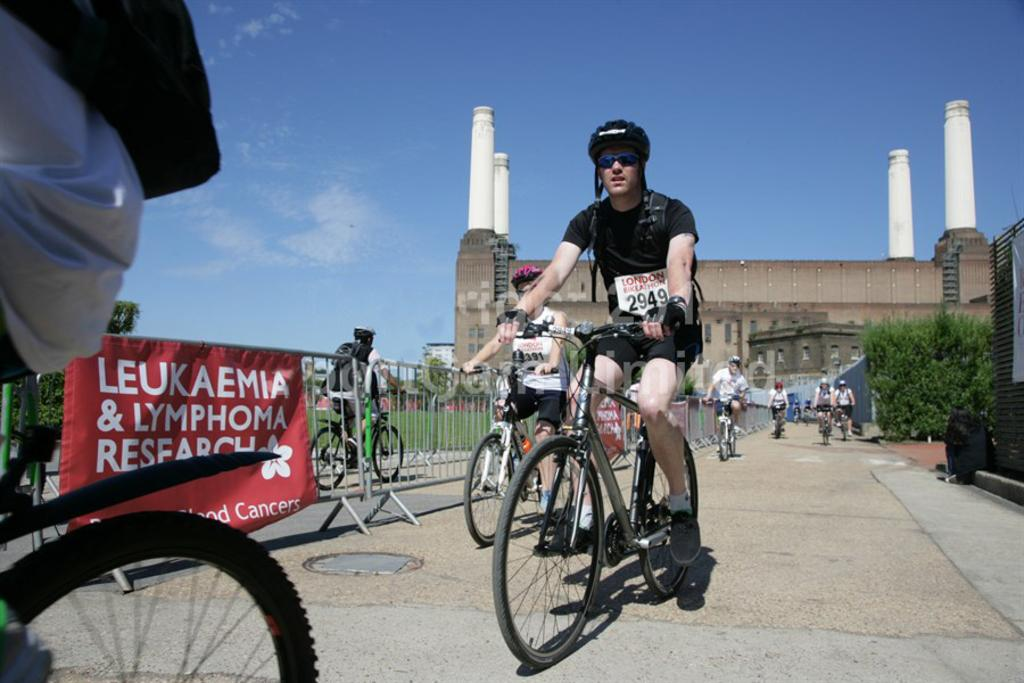What are the persons in the image doing? The persons in the image are riding bicycles. What can be seen in the background of the image? There is an iron fencing, a building, a tree, and the sky visible in the image. What else is present in the image? There is a poster in the image. How does the lock on the bicycle work in the image? There is no lock visible on the bicycles in the image. What type of division is present in the image? There is no division mentioned or visible in the image. 